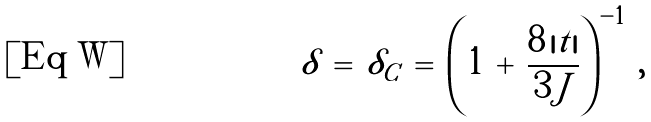Convert formula to latex. <formula><loc_0><loc_0><loc_500><loc_500>\delta \, = \, \delta _ { C } \, = \, \left ( 1 \, + \, \frac { 8 \, | t | } { 3 \, J } \right ) ^ { - 1 } \, ,</formula> 